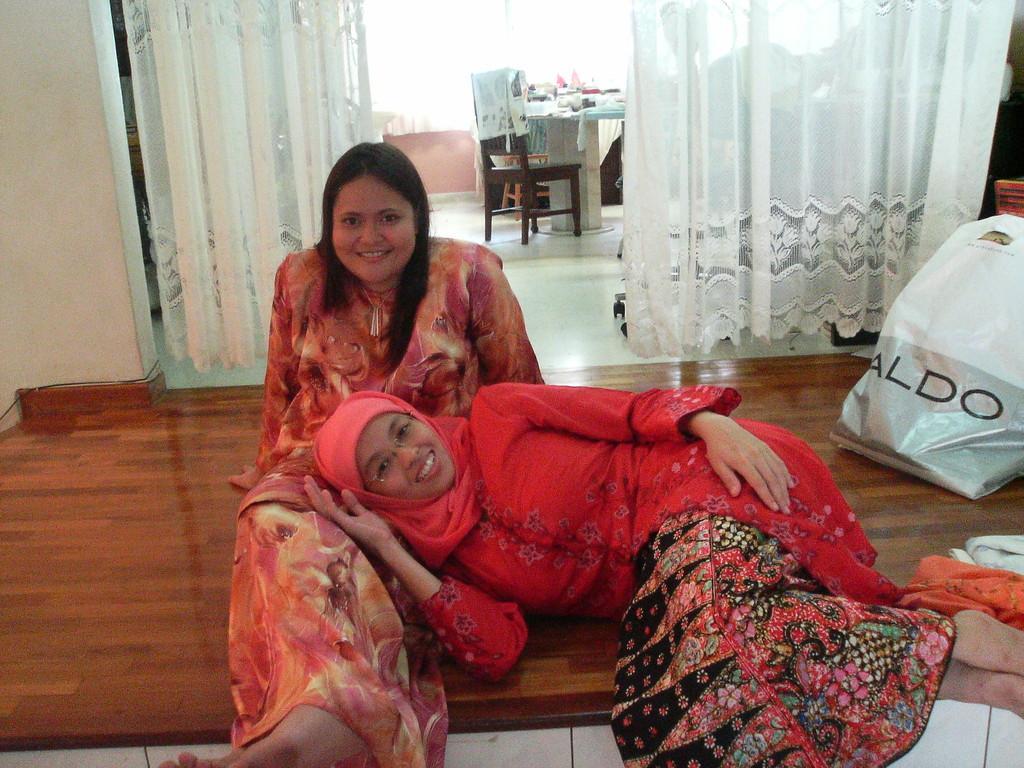Describe this image in one or two sentences. In this picture there are two persons this person sitting on the floor. This person lay on women. On the background we can see curtain,chair,table. On the table we can see things. This is floor. This is cover. 